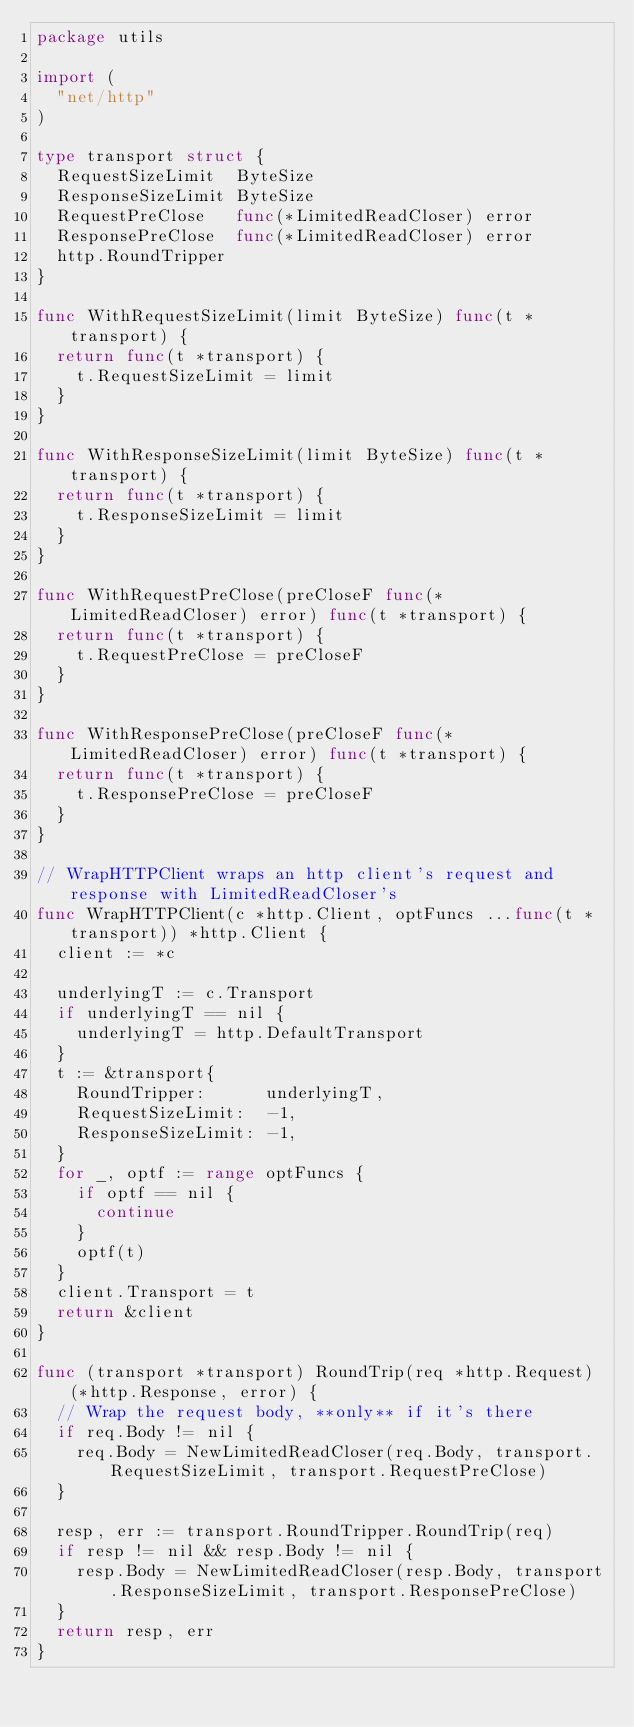Convert code to text. <code><loc_0><loc_0><loc_500><loc_500><_Go_>package utils

import (
	"net/http"
)

type transport struct {
	RequestSizeLimit  ByteSize
	ResponseSizeLimit ByteSize
	RequestPreClose   func(*LimitedReadCloser) error
	ResponsePreClose  func(*LimitedReadCloser) error
	http.RoundTripper
}

func WithRequestSizeLimit(limit ByteSize) func(t *transport) {
	return func(t *transport) {
		t.RequestSizeLimit = limit
	}
}

func WithResponseSizeLimit(limit ByteSize) func(t *transport) {
	return func(t *transport) {
		t.ResponseSizeLimit = limit
	}
}

func WithRequestPreClose(preCloseF func(*LimitedReadCloser) error) func(t *transport) {
	return func(t *transport) {
		t.RequestPreClose = preCloseF
	}
}

func WithResponsePreClose(preCloseF func(*LimitedReadCloser) error) func(t *transport) {
	return func(t *transport) {
		t.ResponsePreClose = preCloseF
	}
}

// WrapHTTPClient wraps an http client's request and response with LimitedReadCloser's
func WrapHTTPClient(c *http.Client, optFuncs ...func(t *transport)) *http.Client {
	client := *c

	underlyingT := c.Transport
	if underlyingT == nil {
		underlyingT = http.DefaultTransport
	}
	t := &transport{
		RoundTripper:      underlyingT,
		RequestSizeLimit:  -1,
		ResponseSizeLimit: -1,
	}
	for _, optf := range optFuncs {
		if optf == nil {
			continue
		}
		optf(t)
	}
	client.Transport = t
	return &client
}

func (transport *transport) RoundTrip(req *http.Request) (*http.Response, error) {
	// Wrap the request body, **only** if it's there
	if req.Body != nil {
		req.Body = NewLimitedReadCloser(req.Body, transport.RequestSizeLimit, transport.RequestPreClose)
	}

	resp, err := transport.RoundTripper.RoundTrip(req)
	if resp != nil && resp.Body != nil {
		resp.Body = NewLimitedReadCloser(resp.Body, transport.ResponseSizeLimit, transport.ResponsePreClose)
	}
	return resp, err
}
</code> 